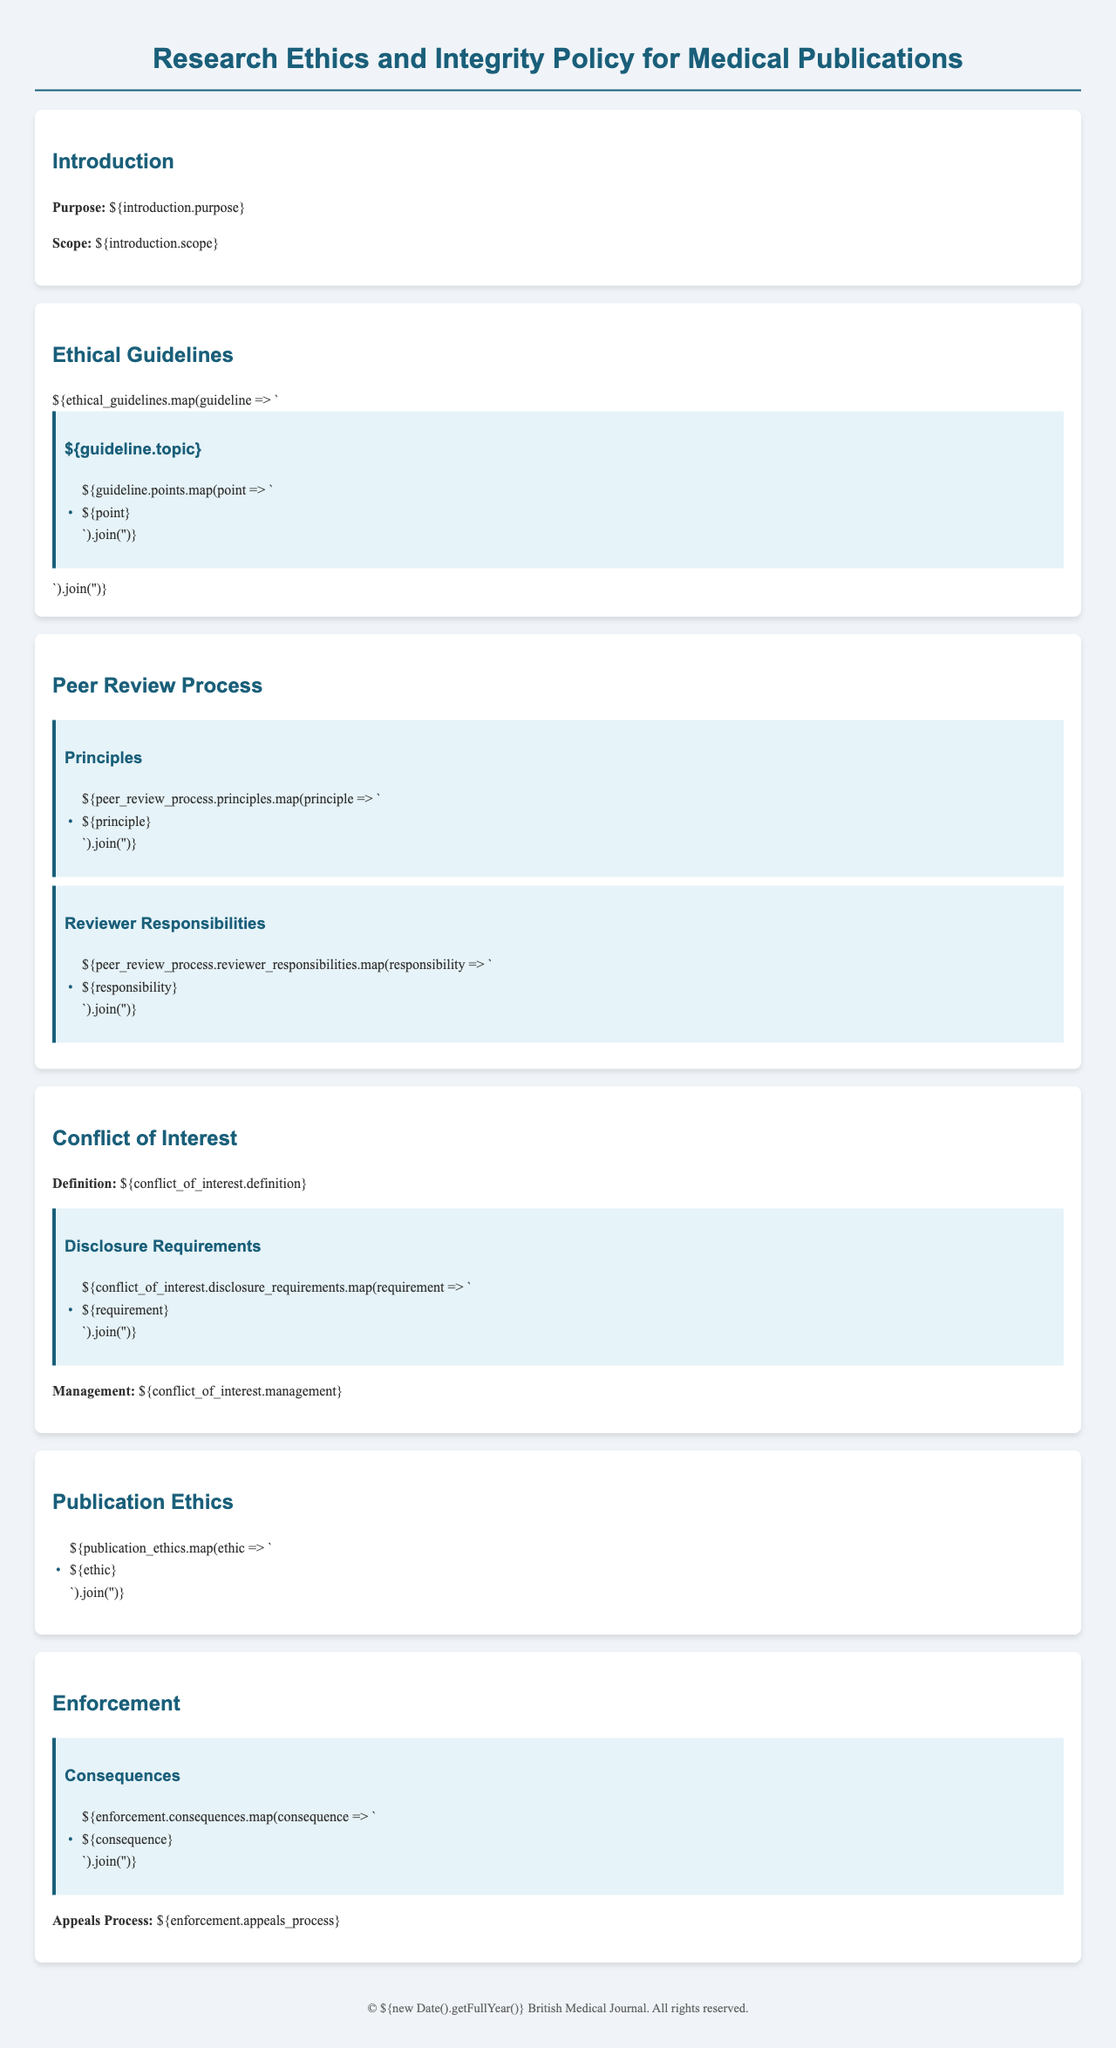What is the purpose of the document? The purpose is stated in the introduction section.
Answer: Purpose: [insert purpose] What does the conflict of interest definition include? The definition is provided in the section on Conflict of Interest.
Answer: Definition: [insert definition] How many principles are outlined in the peer review process? The number of principles can be counted from the Peer Review Process section.
Answer: Number of principles: [insert number] What are the disclosure requirements for conflicts of interest? The disclosure requirements are listed under the Conflict of Interest section.
Answer: Disclosure Requirements: [insert requirements] What should reviewers be responsible for according to the document? Responsibilities for reviewers are detailed in the Peer Review Process section.
Answer: Reviewer Responsibilities: [insert responsibilities] What is the topic of the first ethical guideline? The first ethical guideline topic is found in the Ethical Guidelines section.
Answer: Topic: [insert topic] What are the consequences of violating the publication ethics? Consequences are listed in the Enforcement section of the document.
Answer: Consequences: [insert consequences] What is the appeals process according to the enforcement section? The appeals process is specifically mentioned in the Enforcement section.
Answer: Appeals Process: [insert appeals process] 